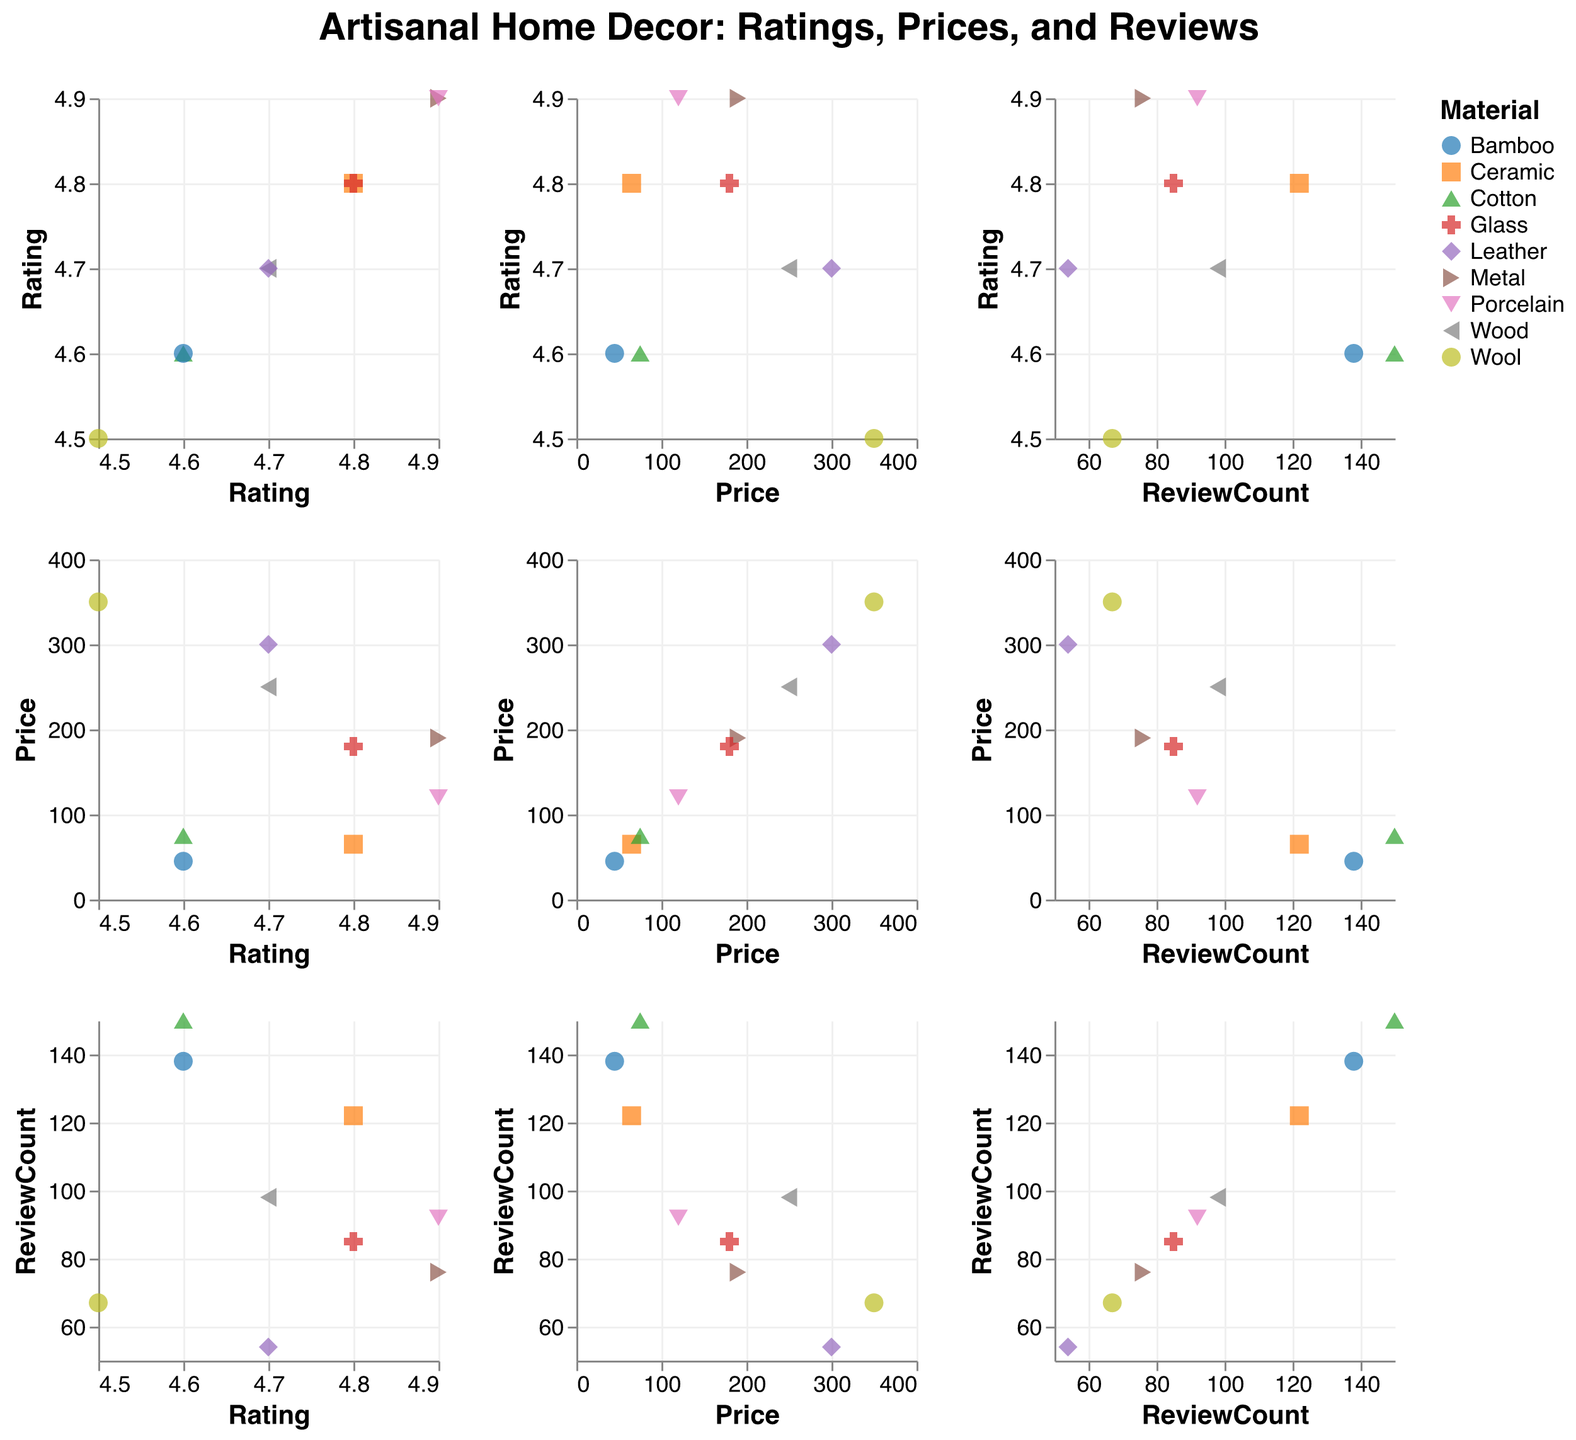What is the general trend between the artisanal home decor price and the number of reviews? The scatter plot with the "Price" on one axis and "ReviewCount" on the other indicates a possible inverse relationship. Generally, lower-priced items tend to get more reviews compared to higher-priced items.
Answer: Lower-priced items have more reviews Which item has the highest rating, and what is its price? By looking at the scatter plot where "Rating" is one of the axes, observe the point at the highest rating value (4.9). Hovering over the point reveals the name of the item and its price: the "Metal Wall Art Sculpture" from SteelArt Studio is one such item with a rating of 4.9 and a price of $190.
Answer: Metal Wall Art Sculpture; $190 Is there any correlation between the material of items and their ratings? By identifying the color and shape coding for different materials (e.g., Ceramic, Wood, Cotton, Metal, Wool, Glass, Leather, Porcelain, Bamboo), observe their locations in the scatter plots. Notice that highly-rated items (ratings of 4.8 and above) are prevalent in diverse materials without a clear dominance.
Answer: No strong correlation; high ratings are spread across various materials Do more expensive items generally have fewer reviews? Observe the scatter plots with "Price" on one axis and "ReviewCount" on the other. The distribution indicates that items with a higher price generally trend towards fewer reviews.
Answer: Yes Among products priced above $100, how many have ratings below 4.7? In the scatter plot matrix, cross-reference the points where prices are more than $100, and then check their ratings. Items like the Organic Wool Area Rug (rating 4.5) and Upcycled Leather Accent Chair (rating 4.7) fit this criterion.
Answer: Two Which artisan's item received the most reviews? Check the scatter plot where "ReviewCount" forms one of the axes. Identify the point with the highest "ReviewCount" value and refer to the tooltip to determine the artisan. The "Handwoven Cotton Throw Blanket" by Harmony Textiles has the most reviews at 150.
Answer: Harmony Textiles What is the average rating of items made from ceramic and porcelain? Locate points marked for ceramic and porcelain. There are two items: Handcrafted Ceramic Vase (rating 4.8) and Hand-Painted Porcelain Dish Set (rating 4.9). Calculate the average rating: (4.8 + 4.9) / 2 = 4.85.
Answer: 4.85 Are items made of wood generally more expensive than items made of bamboo? Look at the scatter plots, identifying the points for wood and bamboo materials. Compare their price ranges. Wood items (Reclaimed Wood Coffee Table $250) are more expensive compared to bamboo items (Bamboo Storage Baskets $45).
Answer: Yes Are most items reviewed in the same year they were made? By examining the tooltip information for "Year" and "ReviewCount," observe the review distribution does not specifically indicate being reviewed within the same year, as some items have reviews spanning multiple years.
Answer: No 